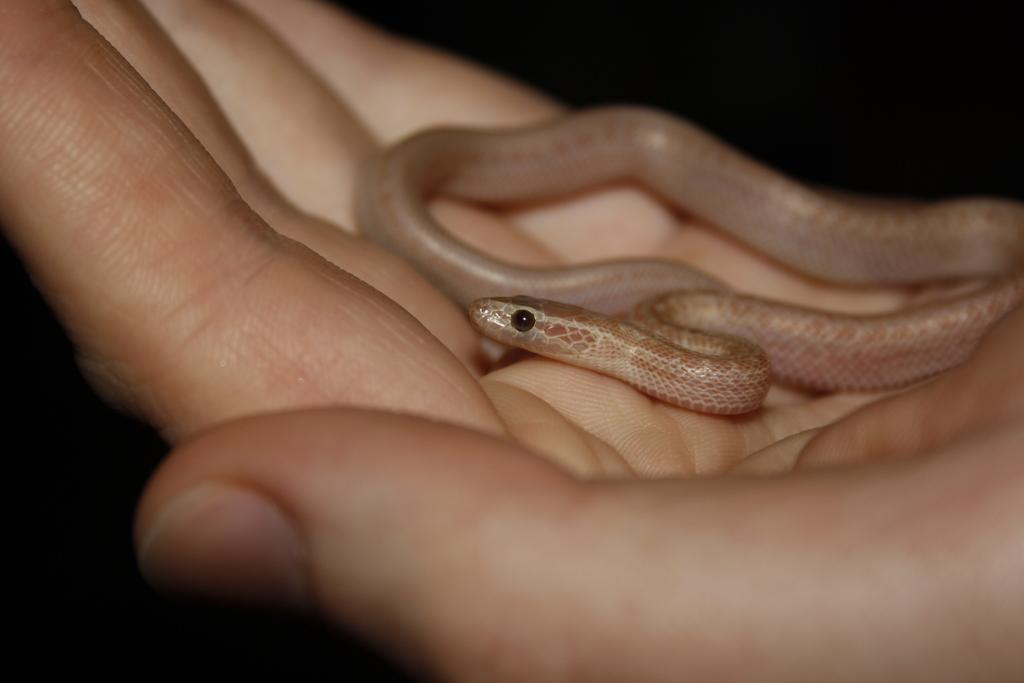What animal is present in the image? There is a snake in the image. Where is the snake located? The snake is on the palm of a person. What can be observed about the background of the image? The background of the image is dark. What type of coal can be seen in the image? There is no coal present in the image. What boundary is visible in the image? There is no boundary visible in the image. 